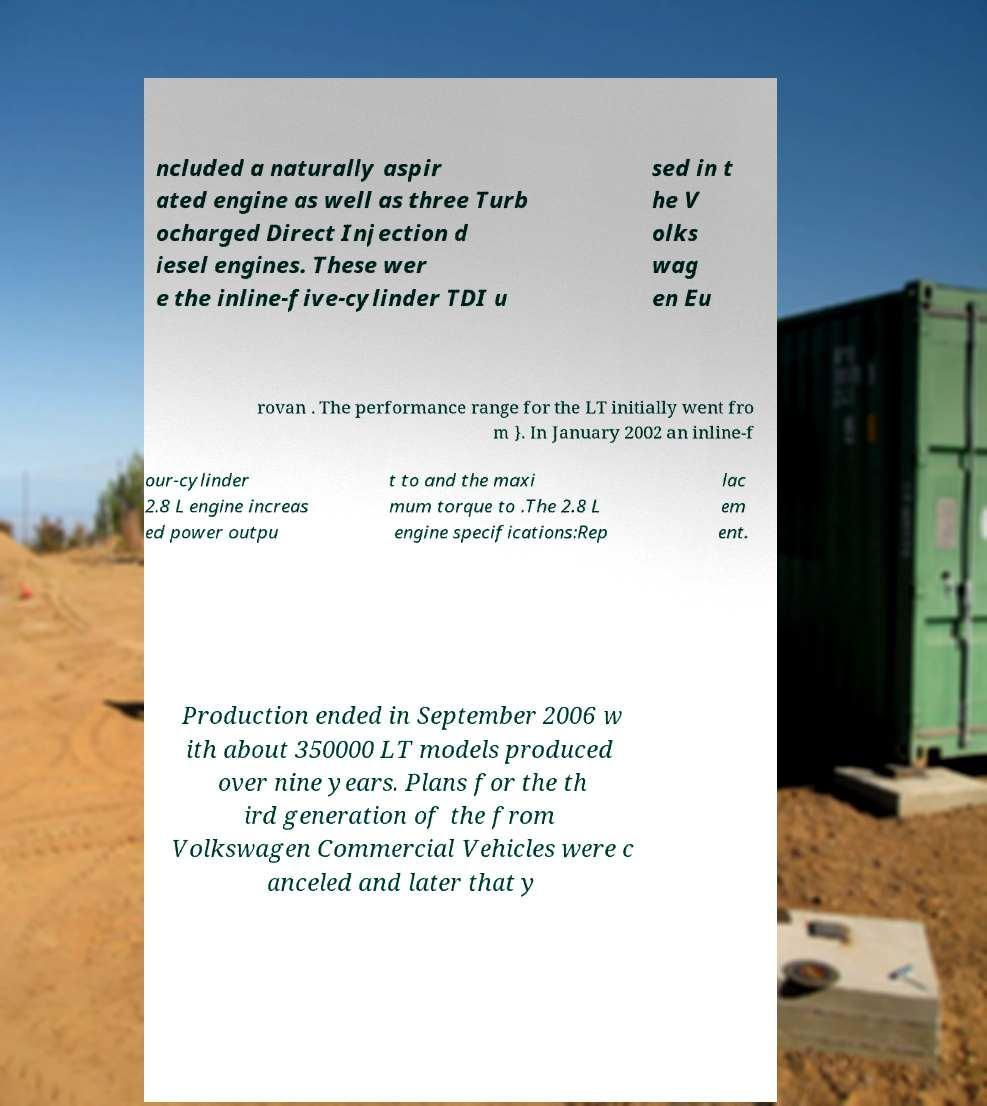Can you accurately transcribe the text from the provided image for me? ncluded a naturally aspir ated engine as well as three Turb ocharged Direct Injection d iesel engines. These wer e the inline-five-cylinder TDI u sed in t he V olks wag en Eu rovan . The performance range for the LT initially went fro m }. In January 2002 an inline-f our-cylinder 2.8 L engine increas ed power outpu t to and the maxi mum torque to .The 2.8 L engine specifications:Rep lac em ent. Production ended in September 2006 w ith about 350000 LT models produced over nine years. Plans for the th ird generation of the from Volkswagen Commercial Vehicles were c anceled and later that y 